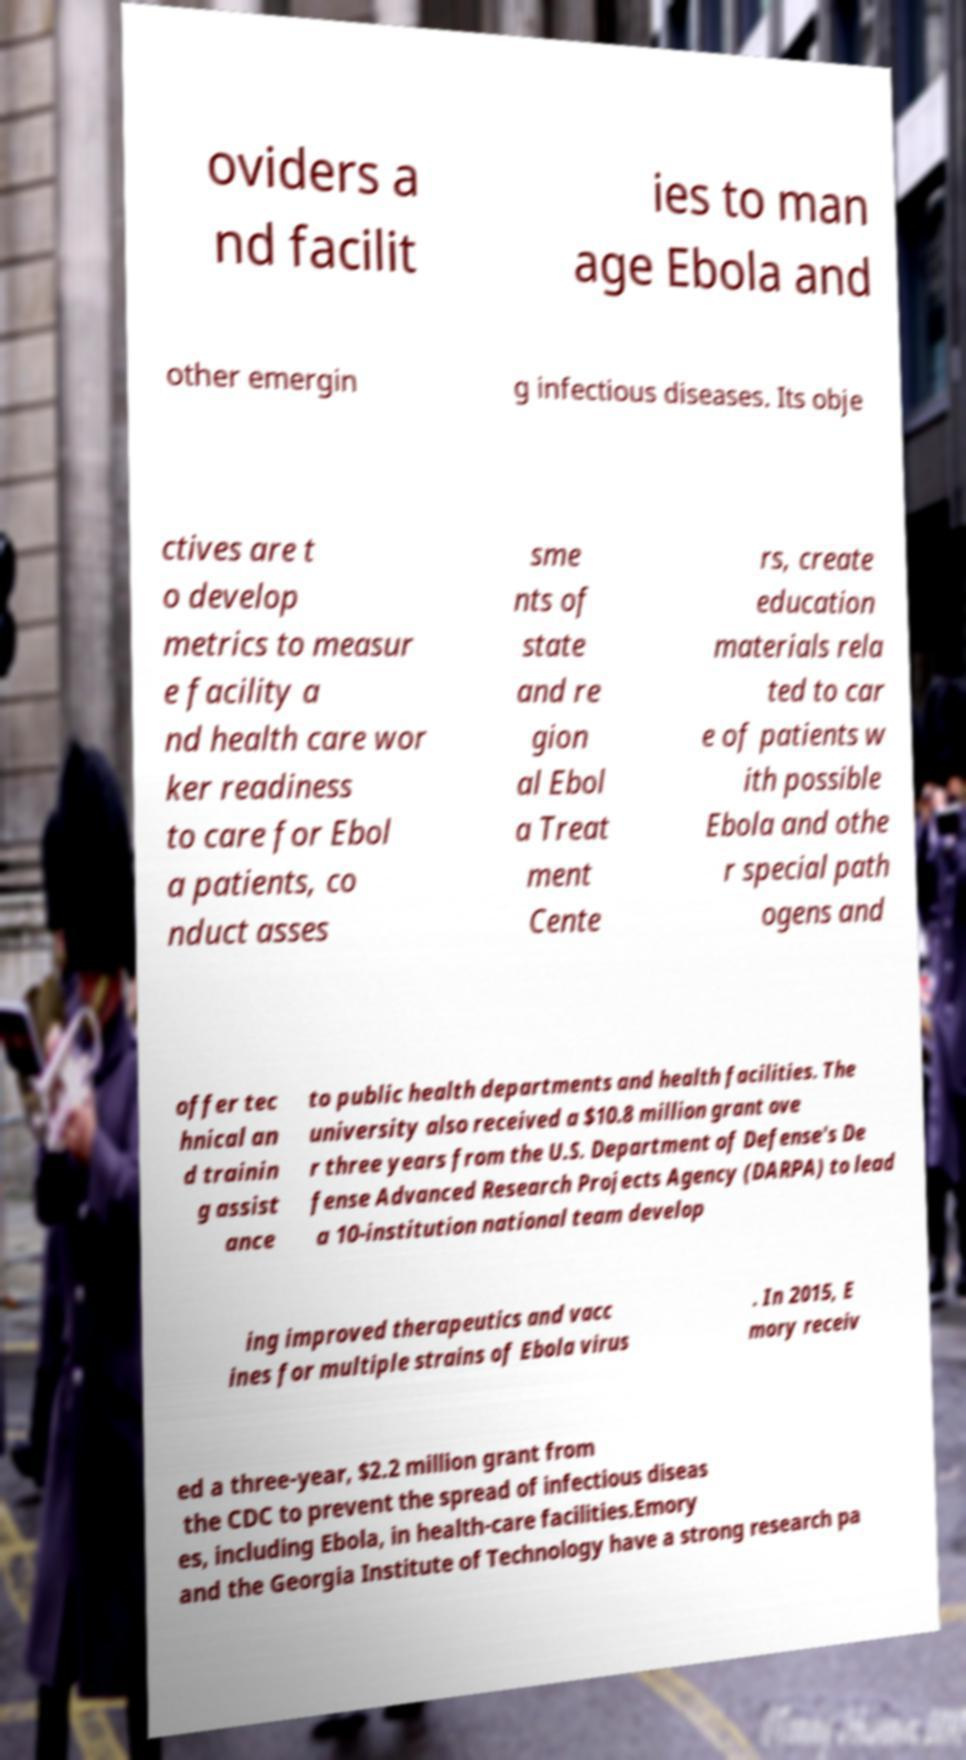Can you accurately transcribe the text from the provided image for me? oviders a nd facilit ies to man age Ebola and other emergin g infectious diseases. Its obje ctives are t o develop metrics to measur e facility a nd health care wor ker readiness to care for Ebol a patients, co nduct asses sme nts of state and re gion al Ebol a Treat ment Cente rs, create education materials rela ted to car e of patients w ith possible Ebola and othe r special path ogens and offer tec hnical an d trainin g assist ance to public health departments and health facilities. The university also received a $10.8 million grant ove r three years from the U.S. Department of Defense's De fense Advanced Research Projects Agency (DARPA) to lead a 10-institution national team develop ing improved therapeutics and vacc ines for multiple strains of Ebola virus . In 2015, E mory receiv ed a three-year, $2.2 million grant from the CDC to prevent the spread of infectious diseas es, including Ebola, in health-care facilities.Emory and the Georgia Institute of Technology have a strong research pa 